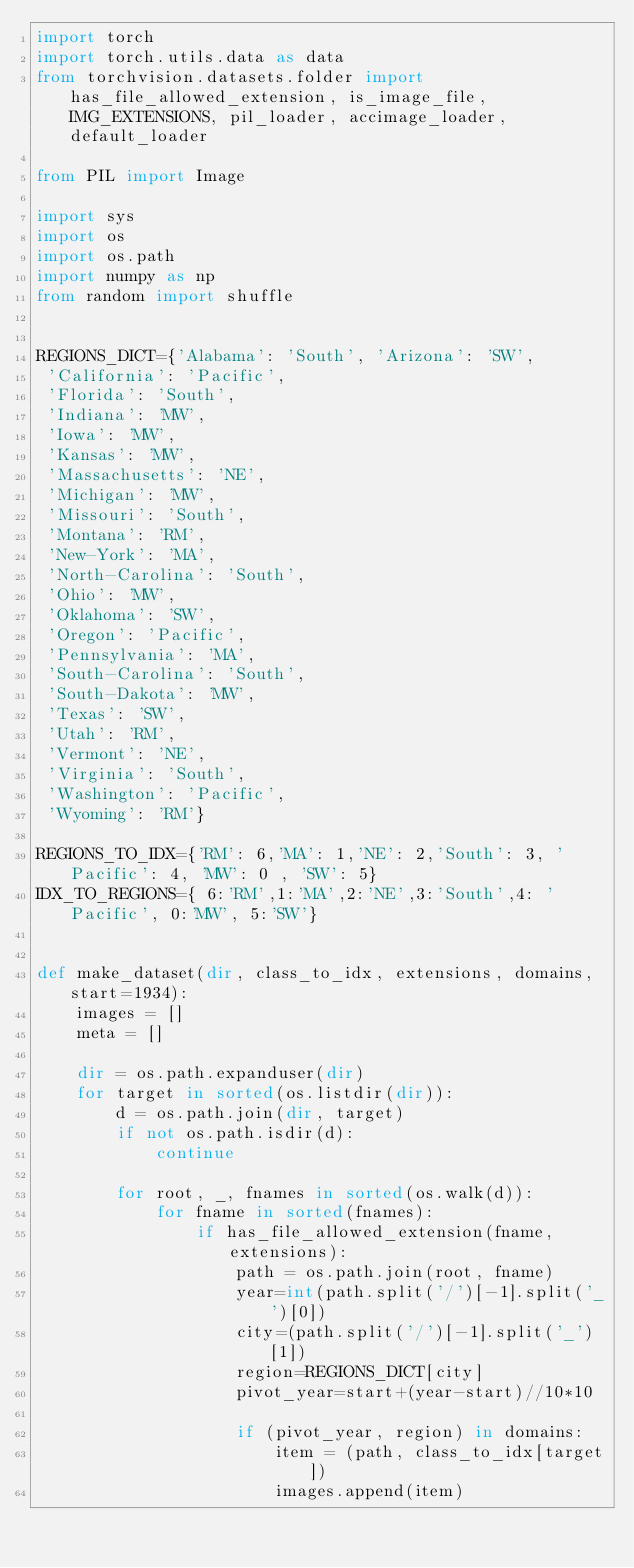Convert code to text. <code><loc_0><loc_0><loc_500><loc_500><_Python_>import torch
import torch.utils.data as data
from torchvision.datasets.folder import  has_file_allowed_extension, is_image_file, IMG_EXTENSIONS, pil_loader, accimage_loader,default_loader

from PIL import Image

import sys
import os
import os.path
import numpy as np
from random import shuffle


REGIONS_DICT={'Alabama': 'South', 'Arizona': 'SW',
 'California': 'Pacific',
 'Florida': 'South',
 'Indiana': 'MW',
 'Iowa': 'MW',
 'Kansas': 'MW',
 'Massachusetts': 'NE',
 'Michigan': 'MW',
 'Missouri': 'South',
 'Montana': 'RM',
 'New-York': 'MA',
 'North-Carolina': 'South',
 'Ohio': 'MW',
 'Oklahoma': 'SW',
 'Oregon': 'Pacific',
 'Pennsylvania': 'MA',
 'South-Carolina': 'South',
 'South-Dakota': 'MW',
 'Texas': 'SW',
 'Utah': 'RM',
 'Vermont': 'NE',
 'Virginia': 'South',
 'Washington': 'Pacific',
 'Wyoming': 'RM'}

REGIONS_TO_IDX={'RM': 6,'MA': 1,'NE': 2,'South': 3, 'Pacific': 4, 'MW': 0 , 'SW': 5}
IDX_TO_REGIONS={ 6:'RM',1:'MA',2:'NE',3:'South',4: 'Pacific', 0:'MW', 5:'SW'}


def make_dataset(dir, class_to_idx, extensions, domains,start=1934):
    images = []
    meta = []

    dir = os.path.expanduser(dir)
    for target in sorted(os.listdir(dir)):
        d = os.path.join(dir, target)
        if not os.path.isdir(d):
            continue

        for root, _, fnames in sorted(os.walk(d)):
            for fname in sorted(fnames):
                if has_file_allowed_extension(fname, extensions):
                    path = os.path.join(root, fname)
                    year=int(path.split('/')[-1].split('_')[0])
                    city=(path.split('/')[-1].split('_')[1])
                    region=REGIONS_DICT[city]
                    pivot_year=start+(year-start)//10*10

                    if (pivot_year, region) in domains:
                        item = (path, class_to_idx[target])
                        images.append(item)</code> 